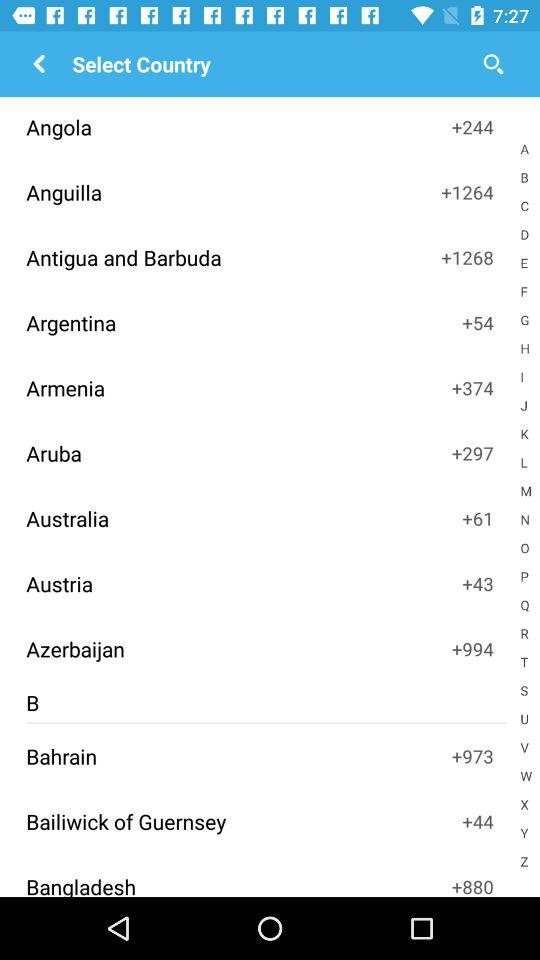What is the name of the application?
When the provided information is insufficient, respond with <no answer>. <no answer> 